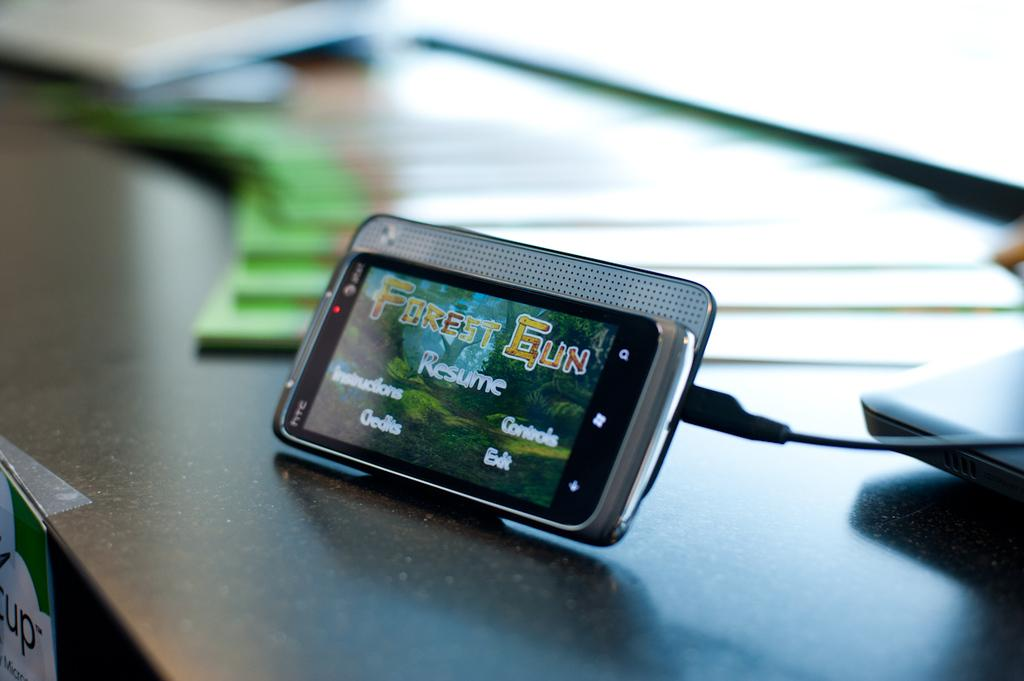<image>
Create a compact narrative representing the image presented. A cell phone plugged in displaying the game Forrest Gun on the screen. 